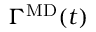<formula> <loc_0><loc_0><loc_500><loc_500>\Gamma ^ { M D } ( t )</formula> 